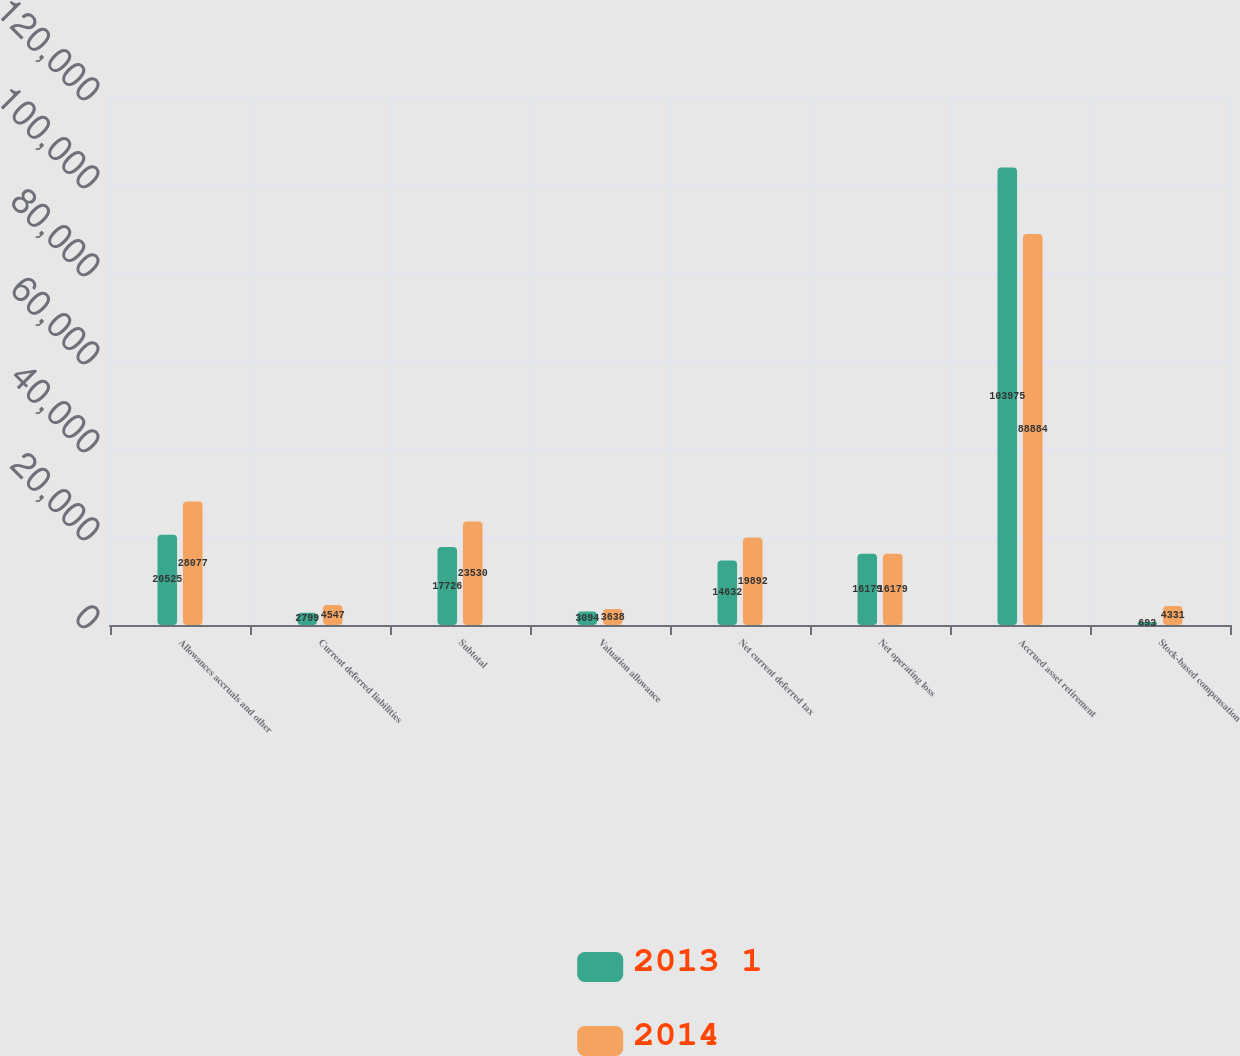Convert chart to OTSL. <chart><loc_0><loc_0><loc_500><loc_500><stacked_bar_chart><ecel><fcel>Allowances accruals and other<fcel>Current deferred liabilities<fcel>Subtotal<fcel>Valuation allowance<fcel>Net current deferred tax<fcel>Net operating loss<fcel>Accrued asset retirement<fcel>Stock-based compensation<nl><fcel>2013 1<fcel>20525<fcel>2799<fcel>17726<fcel>3094<fcel>14632<fcel>16179<fcel>103975<fcel>693<nl><fcel>2014<fcel>28077<fcel>4547<fcel>23530<fcel>3638<fcel>19892<fcel>16179<fcel>88884<fcel>4331<nl></chart> 